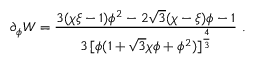<formula> <loc_0><loc_0><loc_500><loc_500>\partial _ { \phi } W = { \frac { 3 ( \chi \xi - 1 ) \phi ^ { 2 } - 2 \sqrt { 3 } ( \chi - \xi ) \phi - 1 } { 3 \, [ \phi ( 1 + \sqrt { 3 } \chi \phi + \phi ^ { 2 } ) ] ^ { \frac { 4 } { 3 } } } } \ .</formula> 